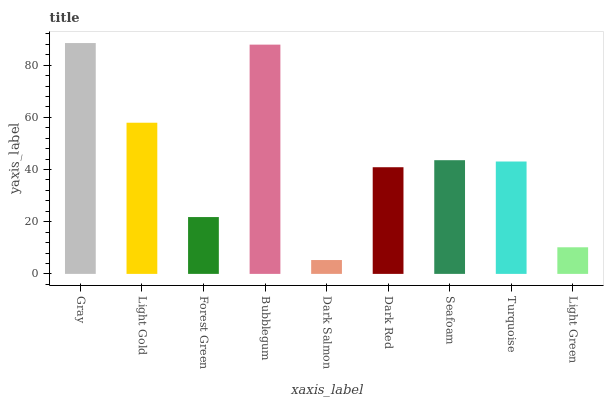Is Dark Salmon the minimum?
Answer yes or no. Yes. Is Gray the maximum?
Answer yes or no. Yes. Is Light Gold the minimum?
Answer yes or no. No. Is Light Gold the maximum?
Answer yes or no. No. Is Gray greater than Light Gold?
Answer yes or no. Yes. Is Light Gold less than Gray?
Answer yes or no. Yes. Is Light Gold greater than Gray?
Answer yes or no. No. Is Gray less than Light Gold?
Answer yes or no. No. Is Turquoise the high median?
Answer yes or no. Yes. Is Turquoise the low median?
Answer yes or no. Yes. Is Dark Salmon the high median?
Answer yes or no. No. Is Dark Red the low median?
Answer yes or no. No. 